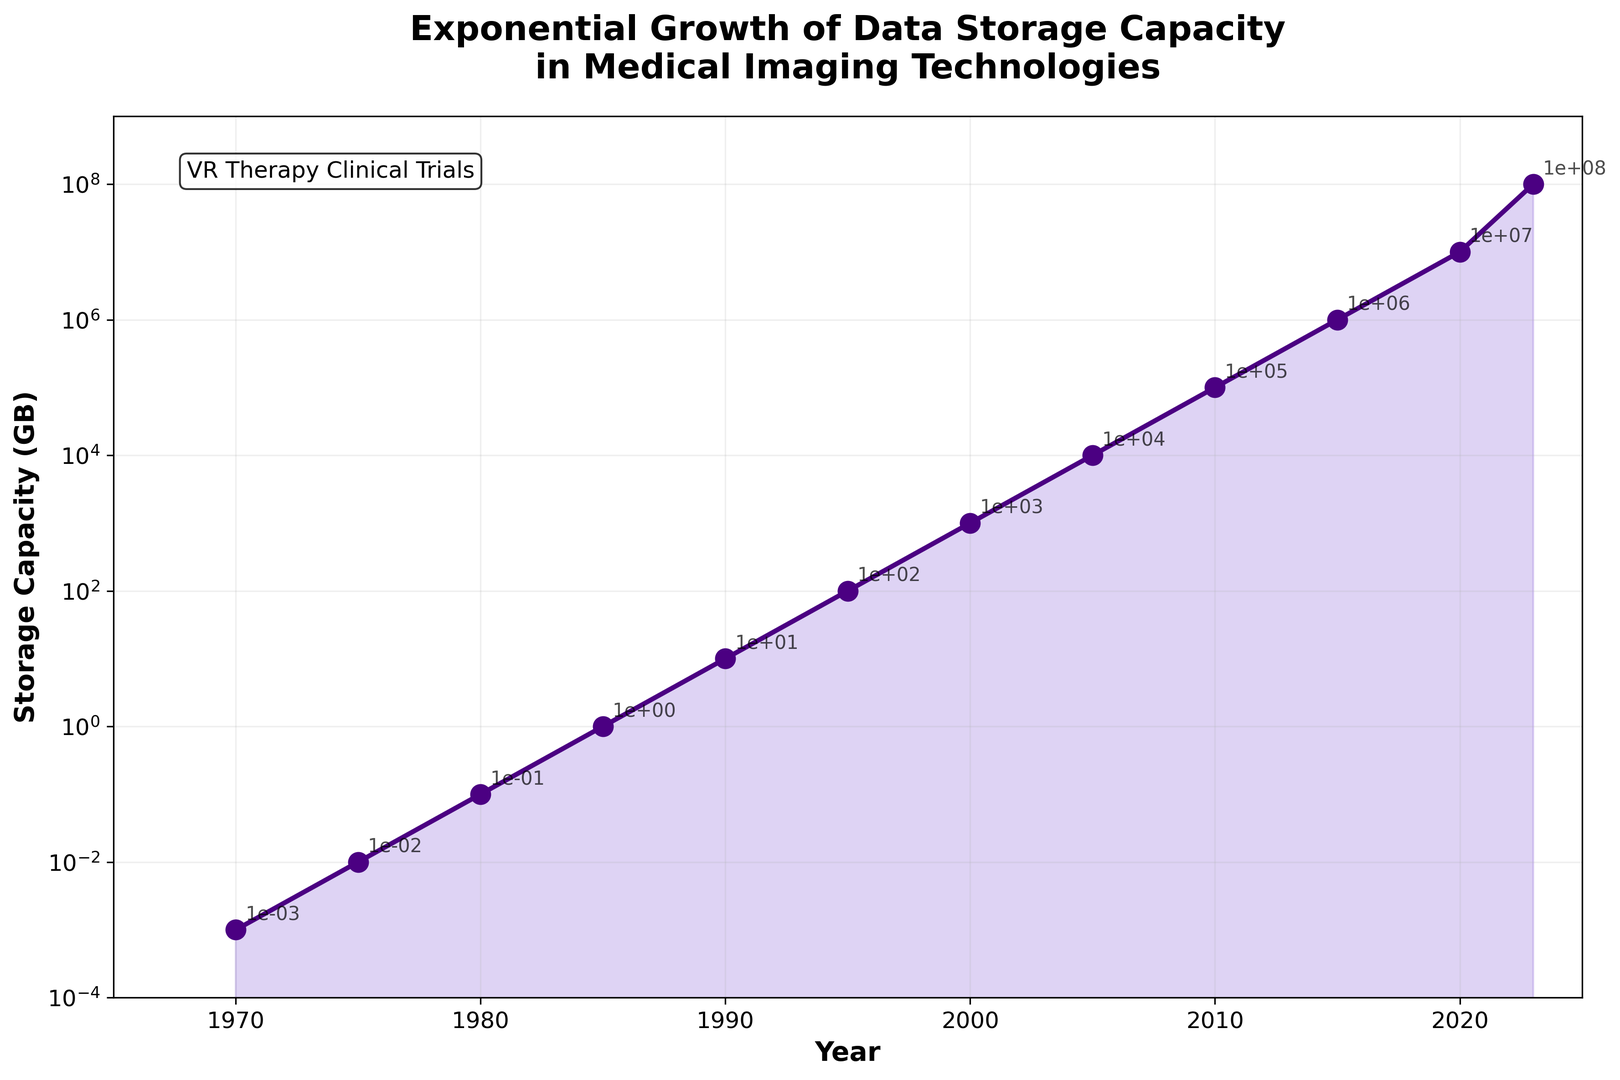what does the y-axis represent in this figure? The y-axis displays the storage capacity in gigabytes (GB) in a logarithmic scale, ranging from 1e-4 (0.0001 GB) to 1e9 (1 billion GB).
Answer: Storage capacity in gigabytes (GB) How much did the storage capacity increase between 1980 and 1990? The storage capacity was 0.1 GB in 1980 and increased to 10 GB in 1990. The difference is 10 - 0.1 = 9.9 GB.
Answer: 9.9 GB Which year saw the biggest jump in storage capacity? By visual inspection, the jump from 2010 (100,000 GB) to 2015 (1,000,000 GB) appears more significant, with an increase of 900,000 GB.
Answer: 2015 How many times greater was the storage capacity in 2023 compared to 1985? In 1985, the storage capacity was 1 GB, and in 2023, it was 100,000,000 GB. The ratio is 100,000,000 / 1 = 100,000,000 times.
Answer: 100,000,000 times What is the average storage capacity in the period spanning from 1990 to 2000? The storage capacity values for the years 1990, 1995, and 2000 are 10, 100, and 1,000 GB, respectively. The average is (10 + 100 + 1,000) / 3 = 370 GB.
Answer: 370 GB By how much did the storage capacity multiply from 1970 to 1975? In 1970, the storage capacity was 0.001 GB, and in 1975, it was 0.01 GB. The multiplication factor is 0.01 / 0.001 = 10 times.
Answer: 10 times Is the growth trend linear or exponential according to the figure? The storage capacity follows an exponential growth trend, as indicated by the logarithmic scale on the y-axis and the large increases over consistent time intervals.
Answer: Exponential How do the data points from 2005 to 2010 compare visually? From a visual perspective, both points indicate a rising trend with the 2010 point (100,000 GB) significantly higher than the 2005 point (10,000 GB), suggesting rapid growth.
Answer: 2010 higher than 2005 Describe the visual pattern formed by the data points in the figure. The data points form an upward curving line on the logarithmic scale, demonstrating a consistent exponential increase in storage capacity over time.
Answer: Upward curving line 